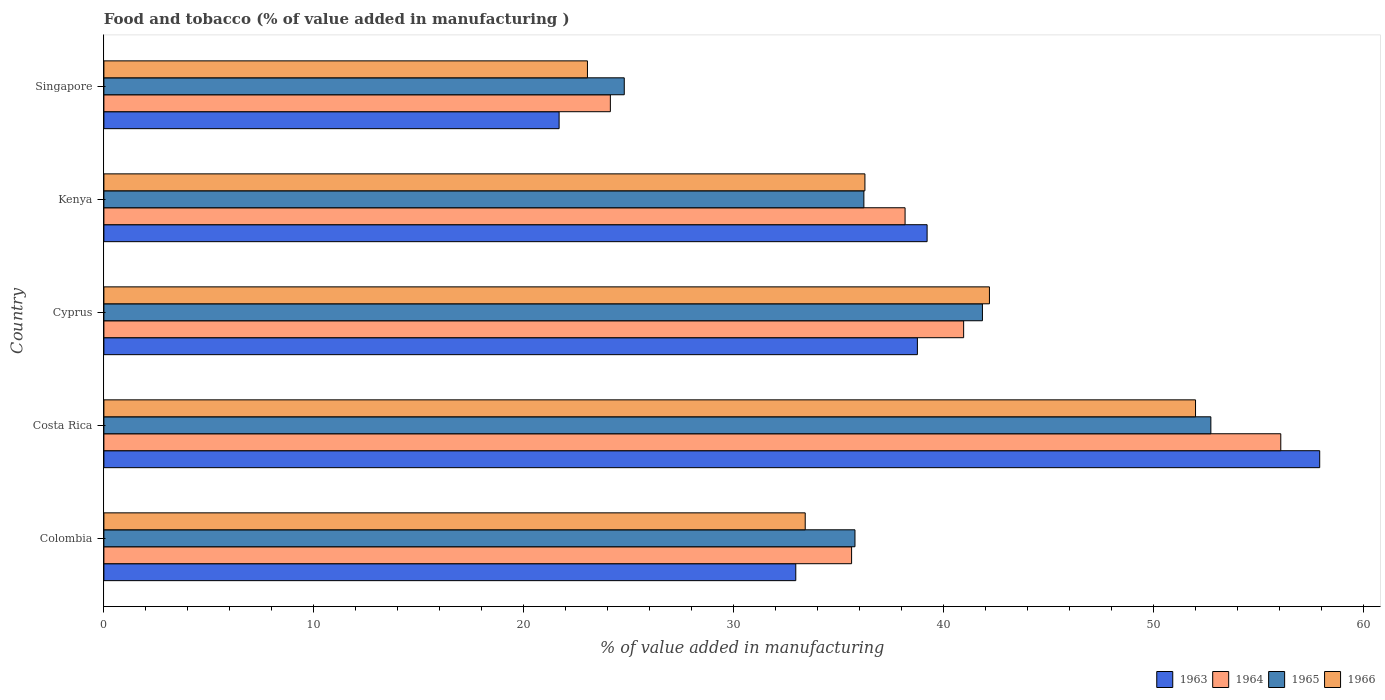How many different coloured bars are there?
Your answer should be very brief. 4. How many groups of bars are there?
Provide a short and direct response. 5. Are the number of bars on each tick of the Y-axis equal?
Provide a succinct answer. Yes. What is the label of the 5th group of bars from the top?
Provide a succinct answer. Colombia. In how many cases, is the number of bars for a given country not equal to the number of legend labels?
Your answer should be compact. 0. What is the value added in manufacturing food and tobacco in 1966 in Singapore?
Make the answer very short. 23.04. Across all countries, what is the maximum value added in manufacturing food and tobacco in 1964?
Give a very brief answer. 56.07. Across all countries, what is the minimum value added in manufacturing food and tobacco in 1964?
Keep it short and to the point. 24.13. In which country was the value added in manufacturing food and tobacco in 1964 maximum?
Ensure brevity in your answer.  Costa Rica. In which country was the value added in manufacturing food and tobacco in 1963 minimum?
Give a very brief answer. Singapore. What is the total value added in manufacturing food and tobacco in 1966 in the graph?
Provide a short and direct response. 186.89. What is the difference between the value added in manufacturing food and tobacco in 1965 in Costa Rica and that in Singapore?
Your answer should be very brief. 27.94. What is the difference between the value added in manufacturing food and tobacco in 1966 in Colombia and the value added in manufacturing food and tobacco in 1964 in Costa Rica?
Ensure brevity in your answer.  -22.66. What is the average value added in manufacturing food and tobacco in 1965 per country?
Offer a terse response. 38.27. What is the difference between the value added in manufacturing food and tobacco in 1964 and value added in manufacturing food and tobacco in 1965 in Colombia?
Offer a terse response. -0.16. What is the ratio of the value added in manufacturing food and tobacco in 1964 in Kenya to that in Singapore?
Offer a very short reply. 1.58. Is the value added in manufacturing food and tobacco in 1963 in Cyprus less than that in Singapore?
Your answer should be very brief. No. Is the difference between the value added in manufacturing food and tobacco in 1964 in Colombia and Cyprus greater than the difference between the value added in manufacturing food and tobacco in 1965 in Colombia and Cyprus?
Provide a short and direct response. Yes. What is the difference between the highest and the second highest value added in manufacturing food and tobacco in 1963?
Your answer should be compact. 18.7. What is the difference between the highest and the lowest value added in manufacturing food and tobacco in 1966?
Keep it short and to the point. 28.97. Is it the case that in every country, the sum of the value added in manufacturing food and tobacco in 1966 and value added in manufacturing food and tobacco in 1965 is greater than the sum of value added in manufacturing food and tobacco in 1964 and value added in manufacturing food and tobacco in 1963?
Your answer should be compact. No. What does the 2nd bar from the top in Costa Rica represents?
Make the answer very short. 1965. What does the 2nd bar from the bottom in Kenya represents?
Your answer should be compact. 1964. Is it the case that in every country, the sum of the value added in manufacturing food and tobacco in 1966 and value added in manufacturing food and tobacco in 1963 is greater than the value added in manufacturing food and tobacco in 1965?
Your response must be concise. Yes. How many countries are there in the graph?
Provide a succinct answer. 5. What is the difference between two consecutive major ticks on the X-axis?
Your response must be concise. 10. Does the graph contain any zero values?
Your answer should be very brief. No. Where does the legend appear in the graph?
Give a very brief answer. Bottom right. What is the title of the graph?
Make the answer very short. Food and tobacco (% of value added in manufacturing ). Does "1974" appear as one of the legend labels in the graph?
Offer a terse response. No. What is the label or title of the X-axis?
Provide a succinct answer. % of value added in manufacturing. What is the label or title of the Y-axis?
Give a very brief answer. Country. What is the % of value added in manufacturing in 1963 in Colombia?
Keep it short and to the point. 32.96. What is the % of value added in manufacturing of 1964 in Colombia?
Offer a terse response. 35.62. What is the % of value added in manufacturing in 1965 in Colombia?
Provide a short and direct response. 35.78. What is the % of value added in manufacturing of 1966 in Colombia?
Ensure brevity in your answer.  33.41. What is the % of value added in manufacturing in 1963 in Costa Rica?
Keep it short and to the point. 57.92. What is the % of value added in manufacturing in 1964 in Costa Rica?
Provide a short and direct response. 56.07. What is the % of value added in manufacturing in 1965 in Costa Rica?
Offer a terse response. 52.73. What is the % of value added in manufacturing in 1966 in Costa Rica?
Offer a very short reply. 52. What is the % of value added in manufacturing in 1963 in Cyprus?
Provide a succinct answer. 38.75. What is the % of value added in manufacturing of 1964 in Cyprus?
Offer a terse response. 40.96. What is the % of value added in manufacturing of 1965 in Cyprus?
Provide a succinct answer. 41.85. What is the % of value added in manufacturing of 1966 in Cyprus?
Your answer should be compact. 42.19. What is the % of value added in manufacturing of 1963 in Kenya?
Give a very brief answer. 39.22. What is the % of value added in manufacturing of 1964 in Kenya?
Offer a very short reply. 38.17. What is the % of value added in manufacturing of 1965 in Kenya?
Provide a short and direct response. 36.2. What is the % of value added in manufacturing of 1966 in Kenya?
Make the answer very short. 36.25. What is the % of value added in manufacturing in 1963 in Singapore?
Keep it short and to the point. 21.69. What is the % of value added in manufacturing in 1964 in Singapore?
Make the answer very short. 24.13. What is the % of value added in manufacturing in 1965 in Singapore?
Your answer should be very brief. 24.79. What is the % of value added in manufacturing in 1966 in Singapore?
Your response must be concise. 23.04. Across all countries, what is the maximum % of value added in manufacturing of 1963?
Your response must be concise. 57.92. Across all countries, what is the maximum % of value added in manufacturing of 1964?
Your answer should be compact. 56.07. Across all countries, what is the maximum % of value added in manufacturing of 1965?
Provide a succinct answer. 52.73. Across all countries, what is the maximum % of value added in manufacturing of 1966?
Keep it short and to the point. 52. Across all countries, what is the minimum % of value added in manufacturing of 1963?
Provide a short and direct response. 21.69. Across all countries, what is the minimum % of value added in manufacturing of 1964?
Make the answer very short. 24.13. Across all countries, what is the minimum % of value added in manufacturing of 1965?
Your answer should be compact. 24.79. Across all countries, what is the minimum % of value added in manufacturing in 1966?
Your answer should be very brief. 23.04. What is the total % of value added in manufacturing of 1963 in the graph?
Make the answer very short. 190.54. What is the total % of value added in manufacturing in 1964 in the graph?
Offer a very short reply. 194.94. What is the total % of value added in manufacturing in 1965 in the graph?
Your answer should be compact. 191.36. What is the total % of value added in manufacturing in 1966 in the graph?
Keep it short and to the point. 186.89. What is the difference between the % of value added in manufacturing of 1963 in Colombia and that in Costa Rica?
Provide a succinct answer. -24.96. What is the difference between the % of value added in manufacturing in 1964 in Colombia and that in Costa Rica?
Your answer should be compact. -20.45. What is the difference between the % of value added in manufacturing in 1965 in Colombia and that in Costa Rica?
Provide a succinct answer. -16.95. What is the difference between the % of value added in manufacturing of 1966 in Colombia and that in Costa Rica?
Offer a terse response. -18.59. What is the difference between the % of value added in manufacturing in 1963 in Colombia and that in Cyprus?
Provide a succinct answer. -5.79. What is the difference between the % of value added in manufacturing in 1964 in Colombia and that in Cyprus?
Give a very brief answer. -5.34. What is the difference between the % of value added in manufacturing in 1965 in Colombia and that in Cyprus?
Your response must be concise. -6.07. What is the difference between the % of value added in manufacturing in 1966 in Colombia and that in Cyprus?
Your answer should be very brief. -8.78. What is the difference between the % of value added in manufacturing in 1963 in Colombia and that in Kenya?
Provide a succinct answer. -6.26. What is the difference between the % of value added in manufacturing of 1964 in Colombia and that in Kenya?
Provide a succinct answer. -2.55. What is the difference between the % of value added in manufacturing of 1965 in Colombia and that in Kenya?
Offer a very short reply. -0.42. What is the difference between the % of value added in manufacturing of 1966 in Colombia and that in Kenya?
Ensure brevity in your answer.  -2.84. What is the difference between the % of value added in manufacturing of 1963 in Colombia and that in Singapore?
Your answer should be compact. 11.27. What is the difference between the % of value added in manufacturing of 1964 in Colombia and that in Singapore?
Your response must be concise. 11.49. What is the difference between the % of value added in manufacturing in 1965 in Colombia and that in Singapore?
Provide a succinct answer. 10.99. What is the difference between the % of value added in manufacturing in 1966 in Colombia and that in Singapore?
Your answer should be compact. 10.37. What is the difference between the % of value added in manufacturing of 1963 in Costa Rica and that in Cyprus?
Ensure brevity in your answer.  19.17. What is the difference between the % of value added in manufacturing in 1964 in Costa Rica and that in Cyprus?
Ensure brevity in your answer.  15.11. What is the difference between the % of value added in manufacturing in 1965 in Costa Rica and that in Cyprus?
Keep it short and to the point. 10.88. What is the difference between the % of value added in manufacturing of 1966 in Costa Rica and that in Cyprus?
Your response must be concise. 9.82. What is the difference between the % of value added in manufacturing in 1963 in Costa Rica and that in Kenya?
Your answer should be compact. 18.7. What is the difference between the % of value added in manufacturing in 1964 in Costa Rica and that in Kenya?
Provide a short and direct response. 17.9. What is the difference between the % of value added in manufacturing of 1965 in Costa Rica and that in Kenya?
Provide a succinct answer. 16.53. What is the difference between the % of value added in manufacturing of 1966 in Costa Rica and that in Kenya?
Your response must be concise. 15.75. What is the difference between the % of value added in manufacturing of 1963 in Costa Rica and that in Singapore?
Provide a short and direct response. 36.23. What is the difference between the % of value added in manufacturing of 1964 in Costa Rica and that in Singapore?
Make the answer very short. 31.94. What is the difference between the % of value added in manufacturing in 1965 in Costa Rica and that in Singapore?
Provide a succinct answer. 27.94. What is the difference between the % of value added in manufacturing of 1966 in Costa Rica and that in Singapore?
Give a very brief answer. 28.97. What is the difference between the % of value added in manufacturing in 1963 in Cyprus and that in Kenya?
Your answer should be compact. -0.46. What is the difference between the % of value added in manufacturing of 1964 in Cyprus and that in Kenya?
Offer a very short reply. 2.79. What is the difference between the % of value added in manufacturing of 1965 in Cyprus and that in Kenya?
Your answer should be compact. 5.65. What is the difference between the % of value added in manufacturing in 1966 in Cyprus and that in Kenya?
Your answer should be compact. 5.93. What is the difference between the % of value added in manufacturing in 1963 in Cyprus and that in Singapore?
Offer a terse response. 17.07. What is the difference between the % of value added in manufacturing in 1964 in Cyprus and that in Singapore?
Ensure brevity in your answer.  16.83. What is the difference between the % of value added in manufacturing of 1965 in Cyprus and that in Singapore?
Make the answer very short. 17.06. What is the difference between the % of value added in manufacturing in 1966 in Cyprus and that in Singapore?
Your answer should be very brief. 19.15. What is the difference between the % of value added in manufacturing in 1963 in Kenya and that in Singapore?
Your answer should be very brief. 17.53. What is the difference between the % of value added in manufacturing of 1964 in Kenya and that in Singapore?
Keep it short and to the point. 14.04. What is the difference between the % of value added in manufacturing of 1965 in Kenya and that in Singapore?
Provide a short and direct response. 11.41. What is the difference between the % of value added in manufacturing in 1966 in Kenya and that in Singapore?
Keep it short and to the point. 13.22. What is the difference between the % of value added in manufacturing in 1963 in Colombia and the % of value added in manufacturing in 1964 in Costa Rica?
Provide a short and direct response. -23.11. What is the difference between the % of value added in manufacturing in 1963 in Colombia and the % of value added in manufacturing in 1965 in Costa Rica?
Offer a terse response. -19.77. What is the difference between the % of value added in manufacturing of 1963 in Colombia and the % of value added in manufacturing of 1966 in Costa Rica?
Make the answer very short. -19.04. What is the difference between the % of value added in manufacturing in 1964 in Colombia and the % of value added in manufacturing in 1965 in Costa Rica?
Your response must be concise. -17.11. What is the difference between the % of value added in manufacturing in 1964 in Colombia and the % of value added in manufacturing in 1966 in Costa Rica?
Provide a succinct answer. -16.38. What is the difference between the % of value added in manufacturing of 1965 in Colombia and the % of value added in manufacturing of 1966 in Costa Rica?
Your answer should be compact. -16.22. What is the difference between the % of value added in manufacturing in 1963 in Colombia and the % of value added in manufacturing in 1964 in Cyprus?
Provide a succinct answer. -8. What is the difference between the % of value added in manufacturing in 1963 in Colombia and the % of value added in manufacturing in 1965 in Cyprus?
Offer a terse response. -8.89. What is the difference between the % of value added in manufacturing in 1963 in Colombia and the % of value added in manufacturing in 1966 in Cyprus?
Provide a succinct answer. -9.23. What is the difference between the % of value added in manufacturing of 1964 in Colombia and the % of value added in manufacturing of 1965 in Cyprus?
Keep it short and to the point. -6.23. What is the difference between the % of value added in manufacturing in 1964 in Colombia and the % of value added in manufacturing in 1966 in Cyprus?
Your answer should be very brief. -6.57. What is the difference between the % of value added in manufacturing of 1965 in Colombia and the % of value added in manufacturing of 1966 in Cyprus?
Provide a succinct answer. -6.41. What is the difference between the % of value added in manufacturing in 1963 in Colombia and the % of value added in manufacturing in 1964 in Kenya?
Ensure brevity in your answer.  -5.21. What is the difference between the % of value added in manufacturing of 1963 in Colombia and the % of value added in manufacturing of 1965 in Kenya?
Your answer should be very brief. -3.24. What is the difference between the % of value added in manufacturing of 1963 in Colombia and the % of value added in manufacturing of 1966 in Kenya?
Your answer should be compact. -3.29. What is the difference between the % of value added in manufacturing of 1964 in Colombia and the % of value added in manufacturing of 1965 in Kenya?
Your answer should be compact. -0.58. What is the difference between the % of value added in manufacturing of 1964 in Colombia and the % of value added in manufacturing of 1966 in Kenya?
Offer a very short reply. -0.63. What is the difference between the % of value added in manufacturing in 1965 in Colombia and the % of value added in manufacturing in 1966 in Kenya?
Offer a terse response. -0.47. What is the difference between the % of value added in manufacturing in 1963 in Colombia and the % of value added in manufacturing in 1964 in Singapore?
Your answer should be very brief. 8.83. What is the difference between the % of value added in manufacturing in 1963 in Colombia and the % of value added in manufacturing in 1965 in Singapore?
Offer a very short reply. 8.17. What is the difference between the % of value added in manufacturing of 1963 in Colombia and the % of value added in manufacturing of 1966 in Singapore?
Provide a short and direct response. 9.92. What is the difference between the % of value added in manufacturing of 1964 in Colombia and the % of value added in manufacturing of 1965 in Singapore?
Offer a very short reply. 10.83. What is the difference between the % of value added in manufacturing of 1964 in Colombia and the % of value added in manufacturing of 1966 in Singapore?
Provide a short and direct response. 12.58. What is the difference between the % of value added in manufacturing in 1965 in Colombia and the % of value added in manufacturing in 1966 in Singapore?
Offer a very short reply. 12.74. What is the difference between the % of value added in manufacturing in 1963 in Costa Rica and the % of value added in manufacturing in 1964 in Cyprus?
Keep it short and to the point. 16.96. What is the difference between the % of value added in manufacturing in 1963 in Costa Rica and the % of value added in manufacturing in 1965 in Cyprus?
Provide a short and direct response. 16.07. What is the difference between the % of value added in manufacturing of 1963 in Costa Rica and the % of value added in manufacturing of 1966 in Cyprus?
Your answer should be very brief. 15.73. What is the difference between the % of value added in manufacturing of 1964 in Costa Rica and the % of value added in manufacturing of 1965 in Cyprus?
Offer a very short reply. 14.21. What is the difference between the % of value added in manufacturing in 1964 in Costa Rica and the % of value added in manufacturing in 1966 in Cyprus?
Keep it short and to the point. 13.88. What is the difference between the % of value added in manufacturing in 1965 in Costa Rica and the % of value added in manufacturing in 1966 in Cyprus?
Offer a very short reply. 10.55. What is the difference between the % of value added in manufacturing in 1963 in Costa Rica and the % of value added in manufacturing in 1964 in Kenya?
Provide a short and direct response. 19.75. What is the difference between the % of value added in manufacturing of 1963 in Costa Rica and the % of value added in manufacturing of 1965 in Kenya?
Your answer should be very brief. 21.72. What is the difference between the % of value added in manufacturing of 1963 in Costa Rica and the % of value added in manufacturing of 1966 in Kenya?
Your response must be concise. 21.67. What is the difference between the % of value added in manufacturing in 1964 in Costa Rica and the % of value added in manufacturing in 1965 in Kenya?
Keep it short and to the point. 19.86. What is the difference between the % of value added in manufacturing of 1964 in Costa Rica and the % of value added in manufacturing of 1966 in Kenya?
Provide a succinct answer. 19.81. What is the difference between the % of value added in manufacturing in 1965 in Costa Rica and the % of value added in manufacturing in 1966 in Kenya?
Keep it short and to the point. 16.48. What is the difference between the % of value added in manufacturing in 1963 in Costa Rica and the % of value added in manufacturing in 1964 in Singapore?
Your response must be concise. 33.79. What is the difference between the % of value added in manufacturing in 1963 in Costa Rica and the % of value added in manufacturing in 1965 in Singapore?
Your answer should be very brief. 33.13. What is the difference between the % of value added in manufacturing in 1963 in Costa Rica and the % of value added in manufacturing in 1966 in Singapore?
Make the answer very short. 34.88. What is the difference between the % of value added in manufacturing of 1964 in Costa Rica and the % of value added in manufacturing of 1965 in Singapore?
Your answer should be very brief. 31.28. What is the difference between the % of value added in manufacturing of 1964 in Costa Rica and the % of value added in manufacturing of 1966 in Singapore?
Make the answer very short. 33.03. What is the difference between the % of value added in manufacturing of 1965 in Costa Rica and the % of value added in manufacturing of 1966 in Singapore?
Your response must be concise. 29.7. What is the difference between the % of value added in manufacturing in 1963 in Cyprus and the % of value added in manufacturing in 1964 in Kenya?
Offer a terse response. 0.59. What is the difference between the % of value added in manufacturing of 1963 in Cyprus and the % of value added in manufacturing of 1965 in Kenya?
Your answer should be very brief. 2.55. What is the difference between the % of value added in manufacturing of 1963 in Cyprus and the % of value added in manufacturing of 1966 in Kenya?
Keep it short and to the point. 2.5. What is the difference between the % of value added in manufacturing of 1964 in Cyprus and the % of value added in manufacturing of 1965 in Kenya?
Offer a very short reply. 4.75. What is the difference between the % of value added in manufacturing in 1964 in Cyprus and the % of value added in manufacturing in 1966 in Kenya?
Your answer should be compact. 4.7. What is the difference between the % of value added in manufacturing in 1965 in Cyprus and the % of value added in manufacturing in 1966 in Kenya?
Your response must be concise. 5.6. What is the difference between the % of value added in manufacturing in 1963 in Cyprus and the % of value added in manufacturing in 1964 in Singapore?
Give a very brief answer. 14.63. What is the difference between the % of value added in manufacturing in 1963 in Cyprus and the % of value added in manufacturing in 1965 in Singapore?
Your answer should be very brief. 13.96. What is the difference between the % of value added in manufacturing in 1963 in Cyprus and the % of value added in manufacturing in 1966 in Singapore?
Give a very brief answer. 15.72. What is the difference between the % of value added in manufacturing of 1964 in Cyprus and the % of value added in manufacturing of 1965 in Singapore?
Keep it short and to the point. 16.17. What is the difference between the % of value added in manufacturing in 1964 in Cyprus and the % of value added in manufacturing in 1966 in Singapore?
Your answer should be very brief. 17.92. What is the difference between the % of value added in manufacturing in 1965 in Cyprus and the % of value added in manufacturing in 1966 in Singapore?
Provide a short and direct response. 18.82. What is the difference between the % of value added in manufacturing of 1963 in Kenya and the % of value added in manufacturing of 1964 in Singapore?
Provide a succinct answer. 15.09. What is the difference between the % of value added in manufacturing of 1963 in Kenya and the % of value added in manufacturing of 1965 in Singapore?
Keep it short and to the point. 14.43. What is the difference between the % of value added in manufacturing in 1963 in Kenya and the % of value added in manufacturing in 1966 in Singapore?
Keep it short and to the point. 16.18. What is the difference between the % of value added in manufacturing of 1964 in Kenya and the % of value added in manufacturing of 1965 in Singapore?
Provide a succinct answer. 13.38. What is the difference between the % of value added in manufacturing of 1964 in Kenya and the % of value added in manufacturing of 1966 in Singapore?
Offer a very short reply. 15.13. What is the difference between the % of value added in manufacturing of 1965 in Kenya and the % of value added in manufacturing of 1966 in Singapore?
Provide a succinct answer. 13.17. What is the average % of value added in manufacturing in 1963 per country?
Ensure brevity in your answer.  38.11. What is the average % of value added in manufacturing of 1964 per country?
Your response must be concise. 38.99. What is the average % of value added in manufacturing in 1965 per country?
Your answer should be compact. 38.27. What is the average % of value added in manufacturing in 1966 per country?
Offer a very short reply. 37.38. What is the difference between the % of value added in manufacturing of 1963 and % of value added in manufacturing of 1964 in Colombia?
Provide a short and direct response. -2.66. What is the difference between the % of value added in manufacturing of 1963 and % of value added in manufacturing of 1965 in Colombia?
Your answer should be very brief. -2.82. What is the difference between the % of value added in manufacturing in 1963 and % of value added in manufacturing in 1966 in Colombia?
Offer a very short reply. -0.45. What is the difference between the % of value added in manufacturing in 1964 and % of value added in manufacturing in 1965 in Colombia?
Your response must be concise. -0.16. What is the difference between the % of value added in manufacturing in 1964 and % of value added in manufacturing in 1966 in Colombia?
Your answer should be very brief. 2.21. What is the difference between the % of value added in manufacturing in 1965 and % of value added in manufacturing in 1966 in Colombia?
Make the answer very short. 2.37. What is the difference between the % of value added in manufacturing of 1963 and % of value added in manufacturing of 1964 in Costa Rica?
Your answer should be compact. 1.85. What is the difference between the % of value added in manufacturing in 1963 and % of value added in manufacturing in 1965 in Costa Rica?
Make the answer very short. 5.19. What is the difference between the % of value added in manufacturing of 1963 and % of value added in manufacturing of 1966 in Costa Rica?
Your answer should be very brief. 5.92. What is the difference between the % of value added in manufacturing in 1964 and % of value added in manufacturing in 1965 in Costa Rica?
Provide a short and direct response. 3.33. What is the difference between the % of value added in manufacturing of 1964 and % of value added in manufacturing of 1966 in Costa Rica?
Your answer should be compact. 4.06. What is the difference between the % of value added in manufacturing of 1965 and % of value added in manufacturing of 1966 in Costa Rica?
Provide a short and direct response. 0.73. What is the difference between the % of value added in manufacturing of 1963 and % of value added in manufacturing of 1964 in Cyprus?
Make the answer very short. -2.2. What is the difference between the % of value added in manufacturing in 1963 and % of value added in manufacturing in 1965 in Cyprus?
Make the answer very short. -3.1. What is the difference between the % of value added in manufacturing of 1963 and % of value added in manufacturing of 1966 in Cyprus?
Your response must be concise. -3.43. What is the difference between the % of value added in manufacturing of 1964 and % of value added in manufacturing of 1965 in Cyprus?
Give a very brief answer. -0.9. What is the difference between the % of value added in manufacturing of 1964 and % of value added in manufacturing of 1966 in Cyprus?
Provide a succinct answer. -1.23. What is the difference between the % of value added in manufacturing in 1963 and % of value added in manufacturing in 1964 in Kenya?
Keep it short and to the point. 1.05. What is the difference between the % of value added in manufacturing of 1963 and % of value added in manufacturing of 1965 in Kenya?
Provide a succinct answer. 3.01. What is the difference between the % of value added in manufacturing in 1963 and % of value added in manufacturing in 1966 in Kenya?
Keep it short and to the point. 2.96. What is the difference between the % of value added in manufacturing of 1964 and % of value added in manufacturing of 1965 in Kenya?
Your response must be concise. 1.96. What is the difference between the % of value added in manufacturing in 1964 and % of value added in manufacturing in 1966 in Kenya?
Provide a succinct answer. 1.91. What is the difference between the % of value added in manufacturing in 1965 and % of value added in manufacturing in 1966 in Kenya?
Make the answer very short. -0.05. What is the difference between the % of value added in manufacturing in 1963 and % of value added in manufacturing in 1964 in Singapore?
Provide a short and direct response. -2.44. What is the difference between the % of value added in manufacturing of 1963 and % of value added in manufacturing of 1965 in Singapore?
Give a very brief answer. -3.1. What is the difference between the % of value added in manufacturing in 1963 and % of value added in manufacturing in 1966 in Singapore?
Ensure brevity in your answer.  -1.35. What is the difference between the % of value added in manufacturing in 1964 and % of value added in manufacturing in 1965 in Singapore?
Provide a short and direct response. -0.66. What is the difference between the % of value added in manufacturing of 1964 and % of value added in manufacturing of 1966 in Singapore?
Provide a succinct answer. 1.09. What is the difference between the % of value added in manufacturing of 1965 and % of value added in manufacturing of 1966 in Singapore?
Give a very brief answer. 1.75. What is the ratio of the % of value added in manufacturing in 1963 in Colombia to that in Costa Rica?
Your answer should be compact. 0.57. What is the ratio of the % of value added in manufacturing in 1964 in Colombia to that in Costa Rica?
Offer a very short reply. 0.64. What is the ratio of the % of value added in manufacturing in 1965 in Colombia to that in Costa Rica?
Provide a succinct answer. 0.68. What is the ratio of the % of value added in manufacturing of 1966 in Colombia to that in Costa Rica?
Provide a short and direct response. 0.64. What is the ratio of the % of value added in manufacturing of 1963 in Colombia to that in Cyprus?
Ensure brevity in your answer.  0.85. What is the ratio of the % of value added in manufacturing of 1964 in Colombia to that in Cyprus?
Offer a terse response. 0.87. What is the ratio of the % of value added in manufacturing in 1965 in Colombia to that in Cyprus?
Ensure brevity in your answer.  0.85. What is the ratio of the % of value added in manufacturing of 1966 in Colombia to that in Cyprus?
Ensure brevity in your answer.  0.79. What is the ratio of the % of value added in manufacturing in 1963 in Colombia to that in Kenya?
Give a very brief answer. 0.84. What is the ratio of the % of value added in manufacturing in 1964 in Colombia to that in Kenya?
Make the answer very short. 0.93. What is the ratio of the % of value added in manufacturing in 1965 in Colombia to that in Kenya?
Your response must be concise. 0.99. What is the ratio of the % of value added in manufacturing in 1966 in Colombia to that in Kenya?
Your response must be concise. 0.92. What is the ratio of the % of value added in manufacturing of 1963 in Colombia to that in Singapore?
Offer a terse response. 1.52. What is the ratio of the % of value added in manufacturing in 1964 in Colombia to that in Singapore?
Provide a short and direct response. 1.48. What is the ratio of the % of value added in manufacturing in 1965 in Colombia to that in Singapore?
Offer a terse response. 1.44. What is the ratio of the % of value added in manufacturing in 1966 in Colombia to that in Singapore?
Provide a short and direct response. 1.45. What is the ratio of the % of value added in manufacturing of 1963 in Costa Rica to that in Cyprus?
Ensure brevity in your answer.  1.49. What is the ratio of the % of value added in manufacturing in 1964 in Costa Rica to that in Cyprus?
Your response must be concise. 1.37. What is the ratio of the % of value added in manufacturing in 1965 in Costa Rica to that in Cyprus?
Make the answer very short. 1.26. What is the ratio of the % of value added in manufacturing of 1966 in Costa Rica to that in Cyprus?
Your response must be concise. 1.23. What is the ratio of the % of value added in manufacturing of 1963 in Costa Rica to that in Kenya?
Your answer should be compact. 1.48. What is the ratio of the % of value added in manufacturing of 1964 in Costa Rica to that in Kenya?
Your response must be concise. 1.47. What is the ratio of the % of value added in manufacturing of 1965 in Costa Rica to that in Kenya?
Your answer should be compact. 1.46. What is the ratio of the % of value added in manufacturing in 1966 in Costa Rica to that in Kenya?
Ensure brevity in your answer.  1.43. What is the ratio of the % of value added in manufacturing of 1963 in Costa Rica to that in Singapore?
Provide a succinct answer. 2.67. What is the ratio of the % of value added in manufacturing in 1964 in Costa Rica to that in Singapore?
Provide a succinct answer. 2.32. What is the ratio of the % of value added in manufacturing in 1965 in Costa Rica to that in Singapore?
Your response must be concise. 2.13. What is the ratio of the % of value added in manufacturing of 1966 in Costa Rica to that in Singapore?
Ensure brevity in your answer.  2.26. What is the ratio of the % of value added in manufacturing of 1964 in Cyprus to that in Kenya?
Offer a terse response. 1.07. What is the ratio of the % of value added in manufacturing of 1965 in Cyprus to that in Kenya?
Keep it short and to the point. 1.16. What is the ratio of the % of value added in manufacturing in 1966 in Cyprus to that in Kenya?
Provide a succinct answer. 1.16. What is the ratio of the % of value added in manufacturing of 1963 in Cyprus to that in Singapore?
Your response must be concise. 1.79. What is the ratio of the % of value added in manufacturing in 1964 in Cyprus to that in Singapore?
Offer a very short reply. 1.7. What is the ratio of the % of value added in manufacturing in 1965 in Cyprus to that in Singapore?
Give a very brief answer. 1.69. What is the ratio of the % of value added in manufacturing in 1966 in Cyprus to that in Singapore?
Your response must be concise. 1.83. What is the ratio of the % of value added in manufacturing of 1963 in Kenya to that in Singapore?
Keep it short and to the point. 1.81. What is the ratio of the % of value added in manufacturing in 1964 in Kenya to that in Singapore?
Your answer should be compact. 1.58. What is the ratio of the % of value added in manufacturing of 1965 in Kenya to that in Singapore?
Your response must be concise. 1.46. What is the ratio of the % of value added in manufacturing in 1966 in Kenya to that in Singapore?
Provide a succinct answer. 1.57. What is the difference between the highest and the second highest % of value added in manufacturing of 1963?
Your response must be concise. 18.7. What is the difference between the highest and the second highest % of value added in manufacturing of 1964?
Your answer should be very brief. 15.11. What is the difference between the highest and the second highest % of value added in manufacturing of 1965?
Provide a succinct answer. 10.88. What is the difference between the highest and the second highest % of value added in manufacturing in 1966?
Provide a short and direct response. 9.82. What is the difference between the highest and the lowest % of value added in manufacturing in 1963?
Offer a terse response. 36.23. What is the difference between the highest and the lowest % of value added in manufacturing of 1964?
Provide a short and direct response. 31.94. What is the difference between the highest and the lowest % of value added in manufacturing of 1965?
Provide a succinct answer. 27.94. What is the difference between the highest and the lowest % of value added in manufacturing in 1966?
Make the answer very short. 28.97. 